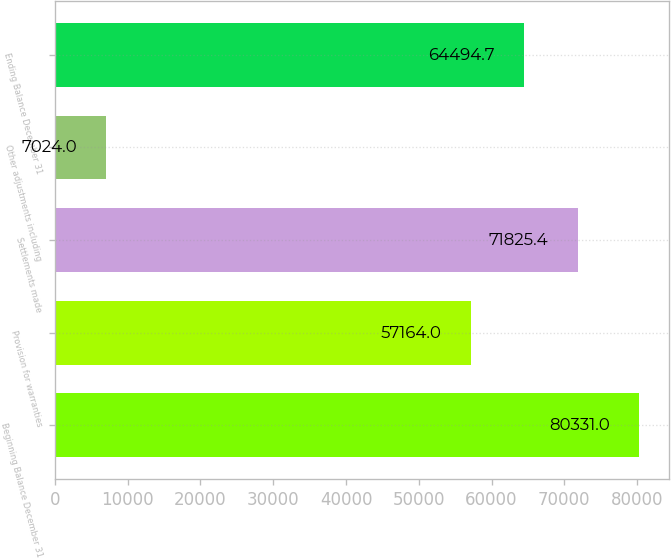Convert chart to OTSL. <chart><loc_0><loc_0><loc_500><loc_500><bar_chart><fcel>Beginning Balance December 31<fcel>Provision for warranties<fcel>Settlements made<fcel>Other adjustments including<fcel>Ending Balance December 31<nl><fcel>80331<fcel>57164<fcel>71825.4<fcel>7024<fcel>64494.7<nl></chart> 